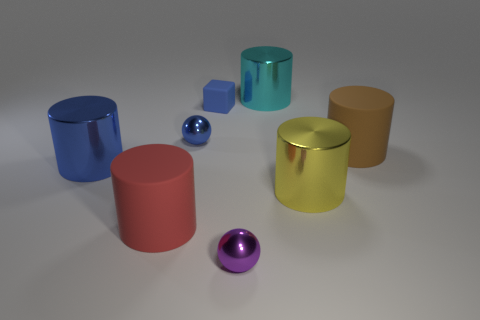Does the big blue thing have the same shape as the red rubber object?
Make the answer very short. Yes. Do the cyan thing and the blue metallic sphere have the same size?
Offer a terse response. No. There is a purple ball that is the same material as the big yellow object; what is its size?
Provide a succinct answer. Small. Is the material of the ball that is on the left side of the purple metal sphere the same as the big blue cylinder?
Keep it short and to the point. Yes. What size is the matte object that is behind the big matte cylinder to the right of the cyan shiny thing?
Your answer should be very brief. Small. There is a metallic sphere on the right side of the sphere on the left side of the ball that is in front of the red rubber cylinder; what size is it?
Your answer should be compact. Small. There is a rubber thing that is to the left of the blue matte object; is its shape the same as the big rubber thing behind the blue shiny cylinder?
Your answer should be compact. Yes. How many other things are the same color as the small matte block?
Provide a succinct answer. 2. There is a shiny cylinder that is behind the block; is its size the same as the small matte block?
Offer a very short reply. No. Is the ball in front of the blue cylinder made of the same material as the sphere behind the big brown object?
Provide a succinct answer. Yes. 